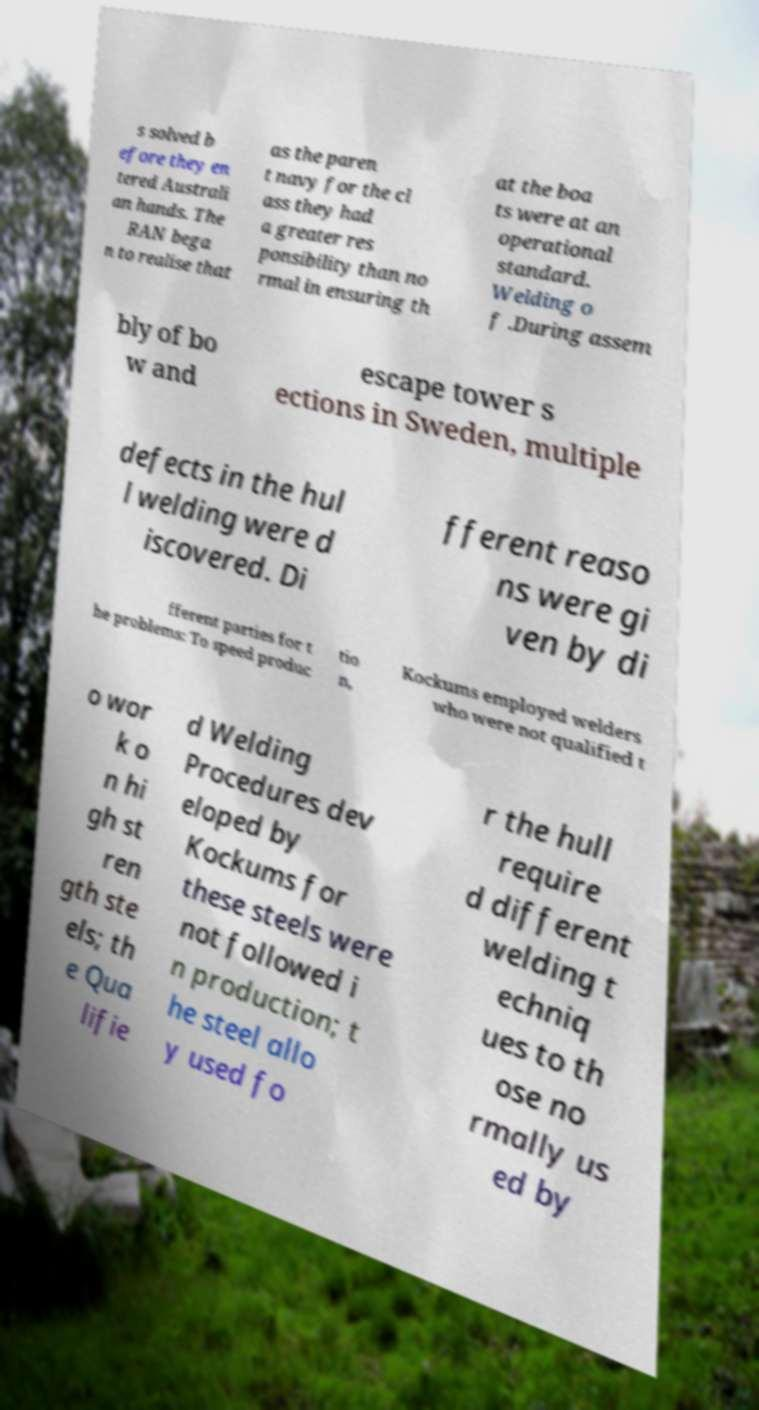Can you accurately transcribe the text from the provided image for me? s solved b efore they en tered Australi an hands. The RAN bega n to realise that as the paren t navy for the cl ass they had a greater res ponsibility than no rmal in ensuring th at the boa ts were at an operational standard. Welding o f .During assem bly of bo w and escape tower s ections in Sweden, multiple defects in the hul l welding were d iscovered. Di fferent reaso ns were gi ven by di fferent parties for t he problems: To speed produc tio n, Kockums employed welders who were not qualified t o wor k o n hi gh st ren gth ste els; th e Qua lifie d Welding Procedures dev eloped by Kockums for these steels were not followed i n production; t he steel allo y used fo r the hull require d different welding t echniq ues to th ose no rmally us ed by 